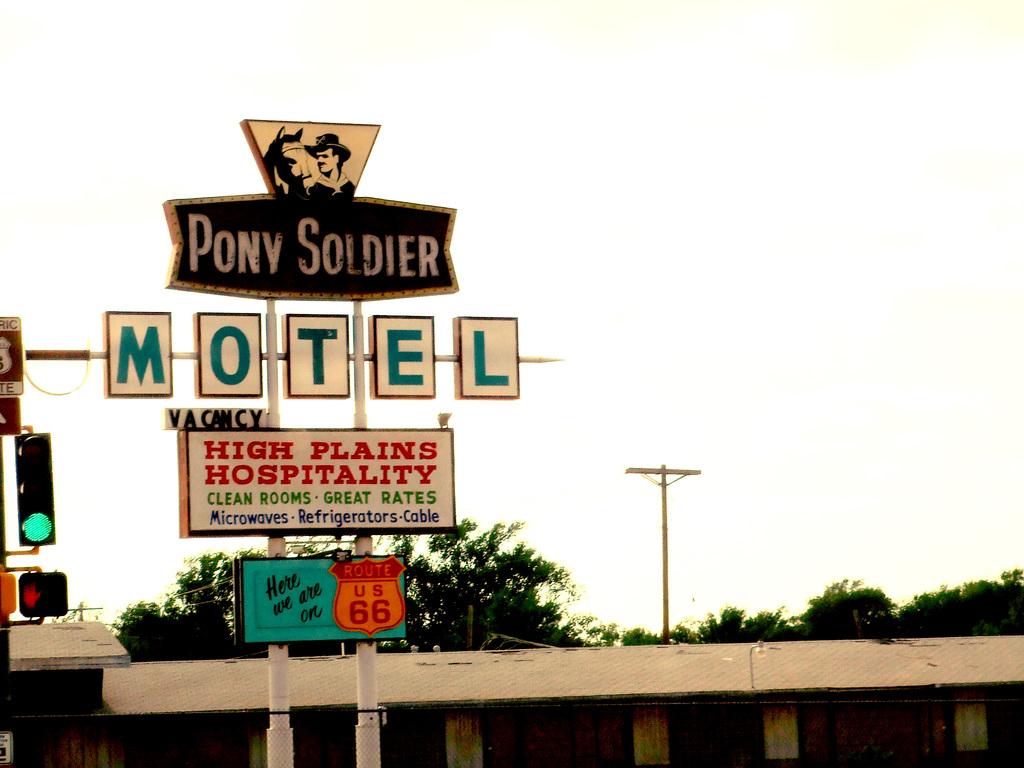Is this for a motel?
Keep it short and to the point. Yes. 